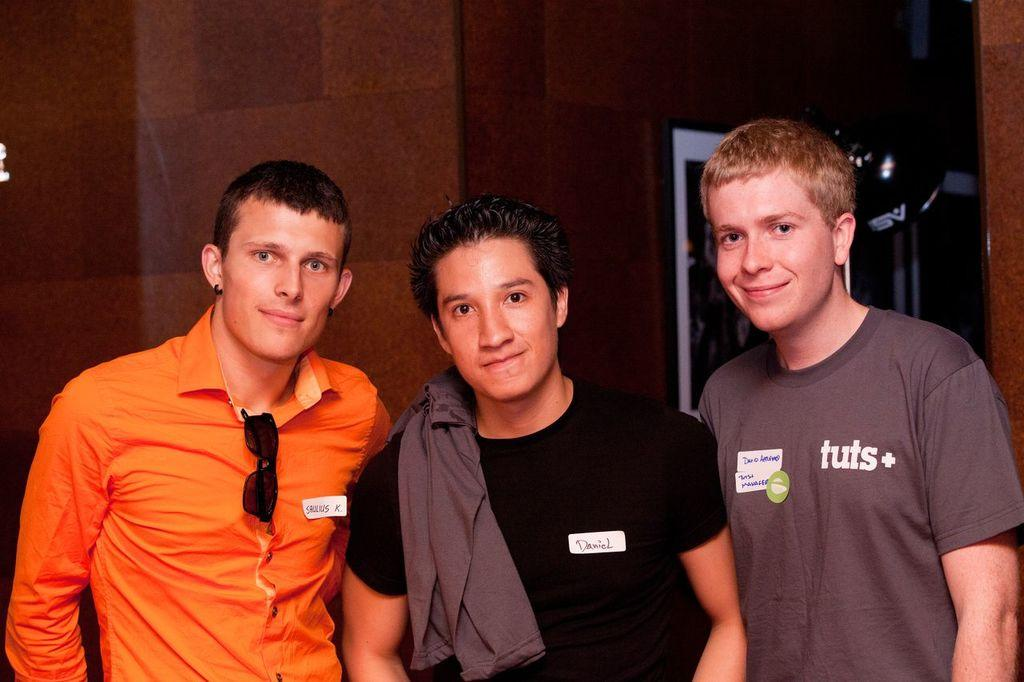What is the main subject of the image? The main subject of the image is people in the center. What can be seen in the background of the image? There is a wall in the background of the image. Are there any objects related to displaying photos in the image? Yes, there is a photo frame in the image. What is the price of the breakfast being served in the image? There is no breakfast being served in the image, so it is not possible to determine its price. 